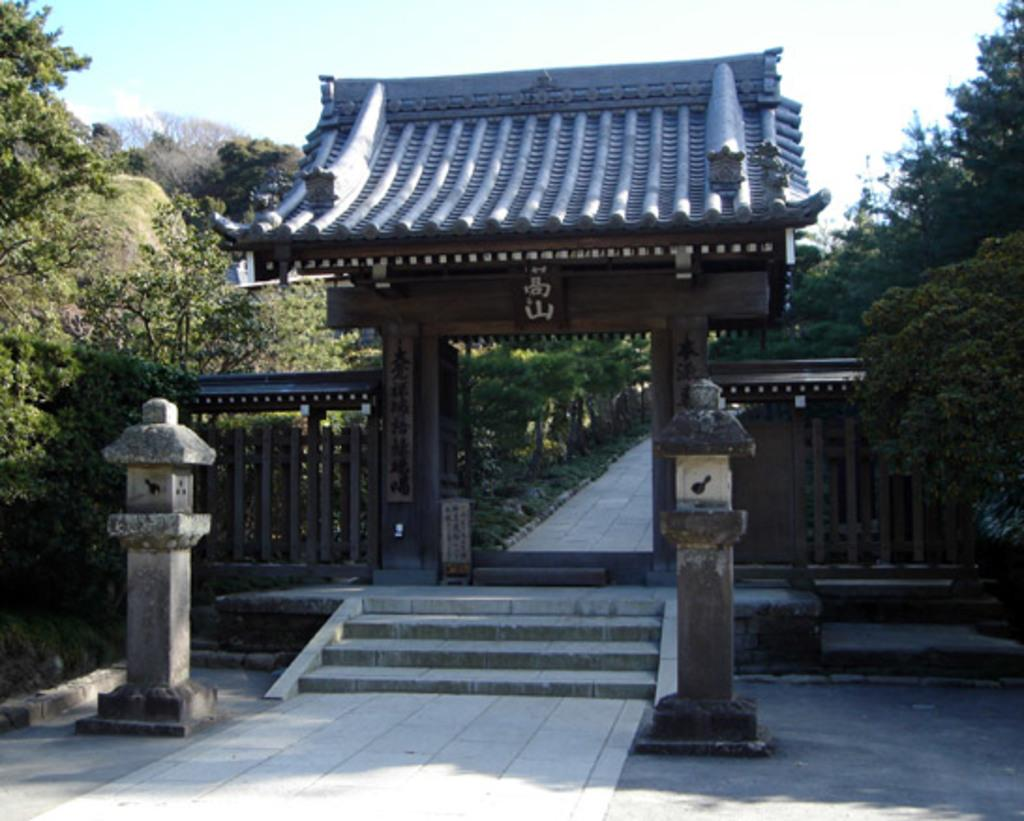What type of surface can be seen in the image? There is ground visible in the image. What structures are present in the image? There are two poles, stairs, an arch, and a path in the image. What type of vegetation is in the image? There are trees in the image. What is visible in the background of the image? The sky is visible in the background of the image. How much wealth is displayed in the image? There is no indication of wealth in the image; it features ground, structures, trees, and the sky. What type of house can be seen in the image? There is no house present in the image. 